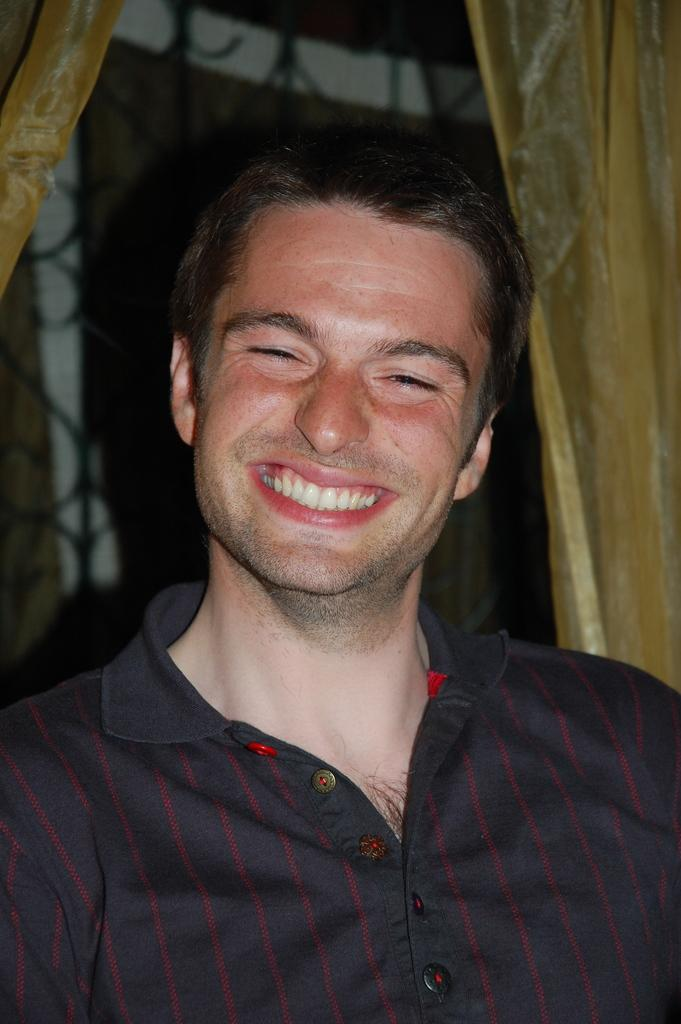Who is present in the image? There is a man in the image. What is the man wearing? The man is wearing a black shirt. What is the man's facial expression? The man is smiling. What type of window treatment is visible in the image? There are curtains visible in the image. What can be seen in the background of the image? There appears to be a window in the background of the image. What type of wound can be seen on the man's side in the image? There is no wound visible on the man's side in the image. What type of bear is present in the image? There is no bear present in the image. 